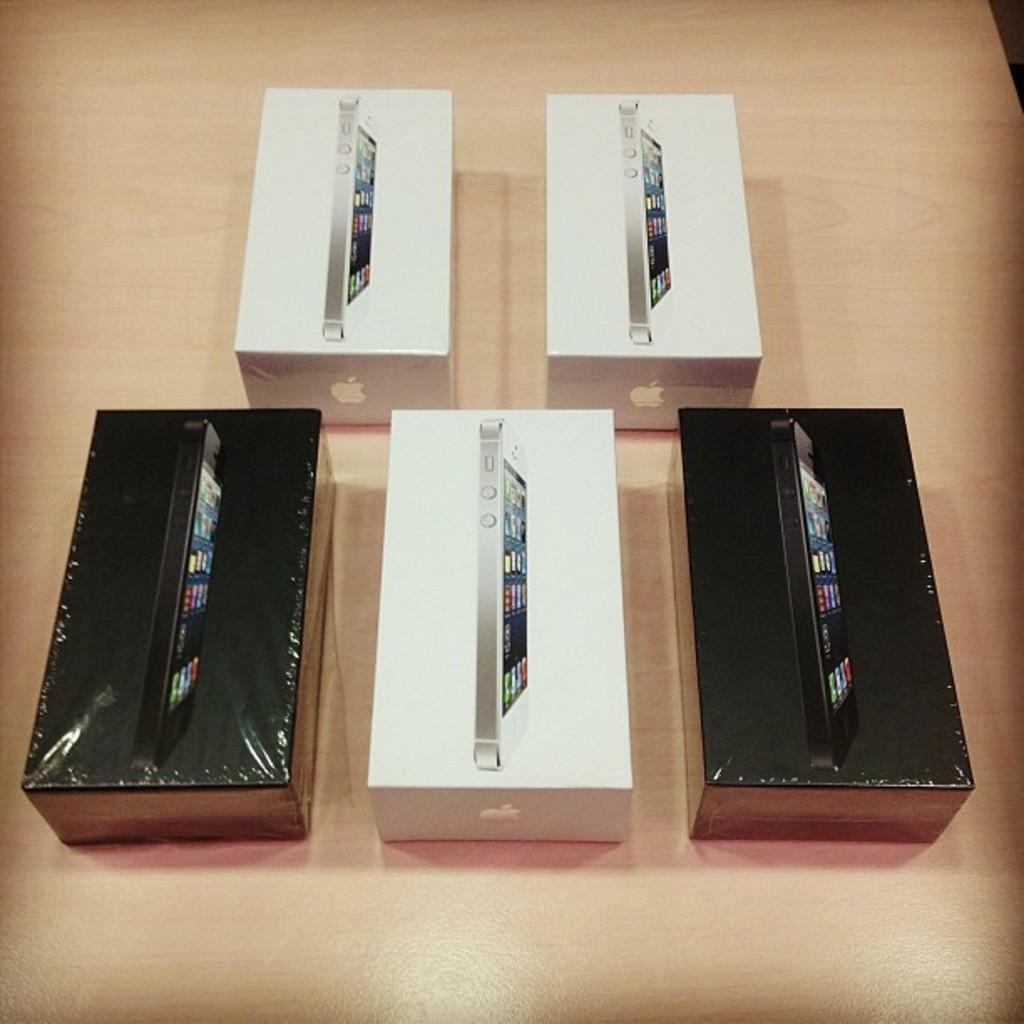Could you give a brief overview of what you see in this image? In this image, we can see some mobile phone boxes kept on the wooden surface. 